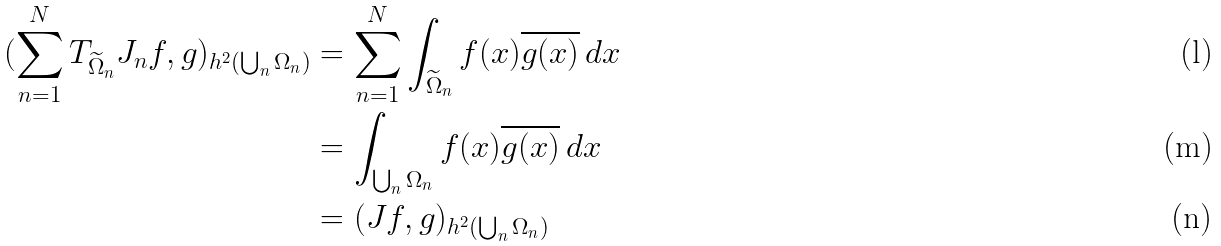Convert formula to latex. <formula><loc_0><loc_0><loc_500><loc_500>( \sum _ { n = 1 } ^ { N } T _ { \widetilde { \Omega } _ { n } } J _ { n } f , g ) _ { h ^ { 2 } \left ( \bigcup _ { n } \Omega _ { n } \right ) } & = \sum _ { n = 1 } ^ { N } \int _ { \widetilde { \Omega } _ { n } } f ( x ) \overline { g ( x ) } \, d x \\ & = \int _ { \bigcup _ { n } \Omega _ { n } } f ( x ) \overline { g ( x ) } \, d x \\ & = ( J f , g ) _ { h ^ { 2 } ( \bigcup _ { n } \Omega _ { n } ) }</formula> 